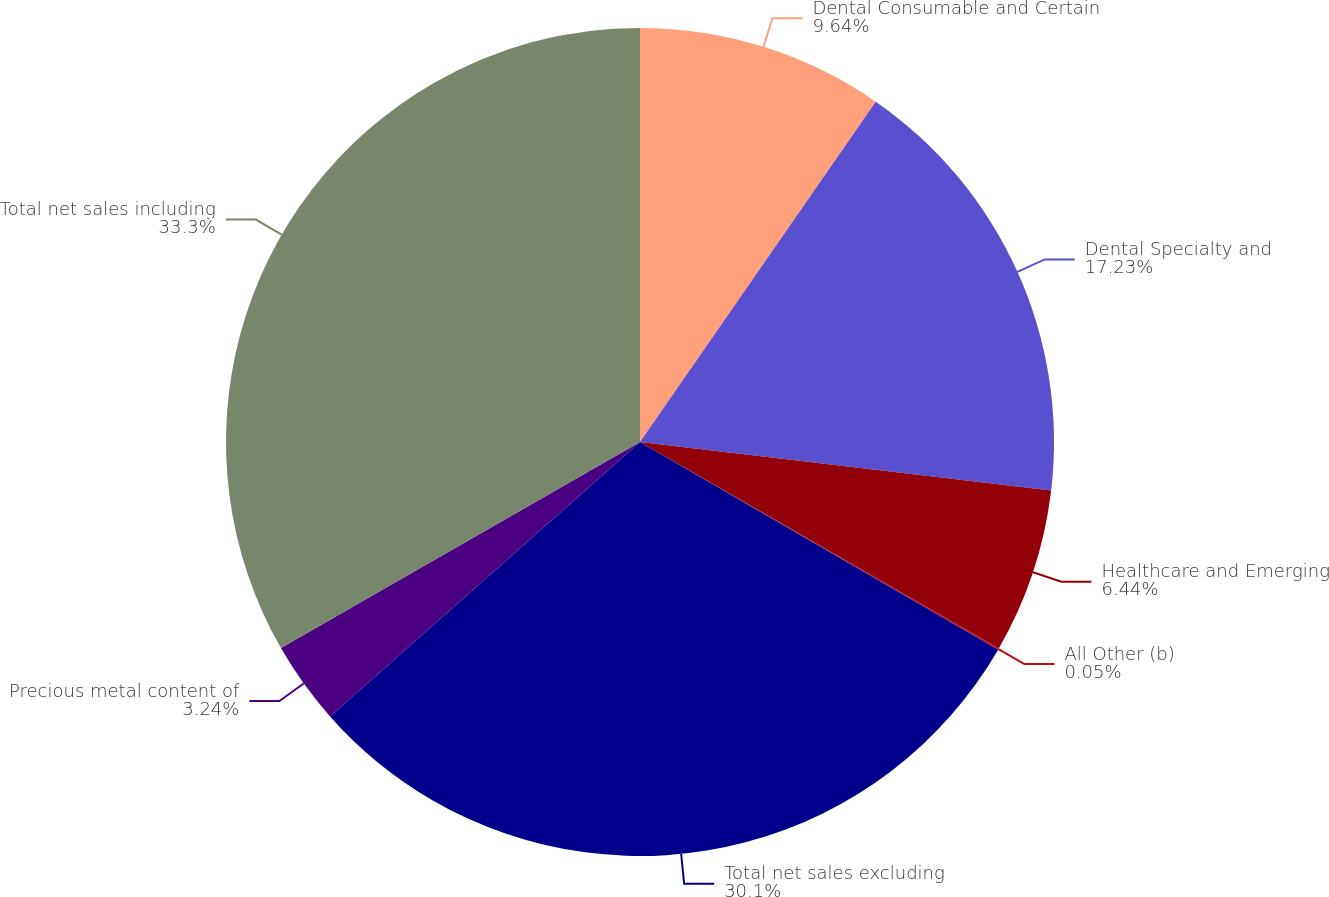<chart> <loc_0><loc_0><loc_500><loc_500><pie_chart><fcel>Dental Consumable and Certain<fcel>Dental Specialty and<fcel>Healthcare and Emerging<fcel>All Other (b)<fcel>Total net sales excluding<fcel>Precious metal content of<fcel>Total net sales including<nl><fcel>9.64%<fcel>17.23%<fcel>6.44%<fcel>0.05%<fcel>30.1%<fcel>3.24%<fcel>33.29%<nl></chart> 